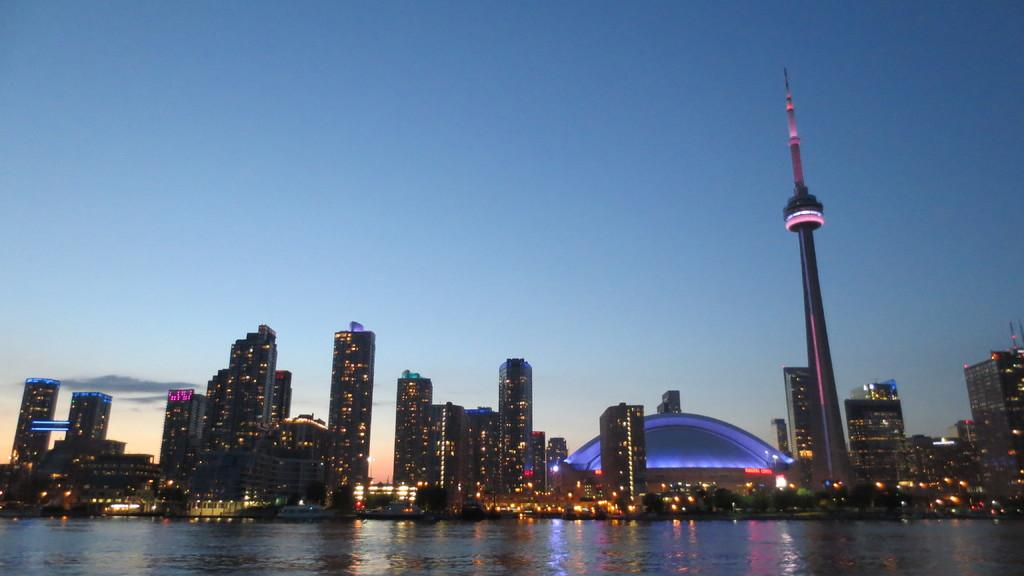What structures are located in the center of the image? There are buildings in the center of the image. What can be seen on the right side of the image? There is a tower on the right side of the image. What is visible in the background of the image? The sky is visible in the background of the image. What is present at the bottom of the image? There is water at the bottom of the image. What type of teeth can be seen on the tower in the image? There are no teeth present on the tower in the image. Is there a chair visible in the image? There is no chair present in the image. 